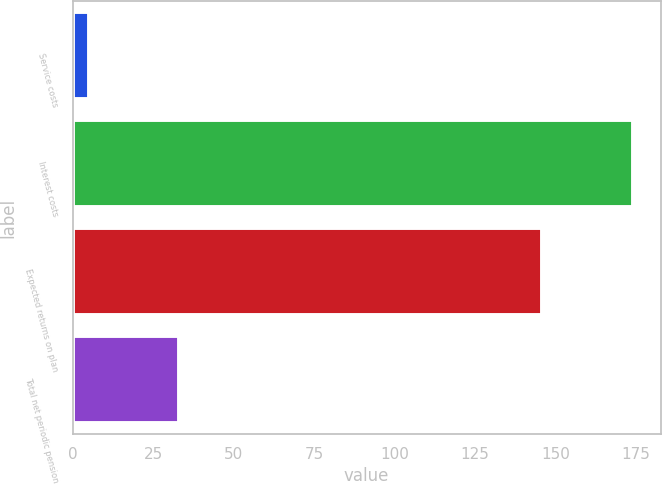Convert chart. <chart><loc_0><loc_0><loc_500><loc_500><bar_chart><fcel>Service costs<fcel>Interest costs<fcel>Expected returns on plan<fcel>Total net periodic pension<nl><fcel>5<fcel>174<fcel>146<fcel>33<nl></chart> 